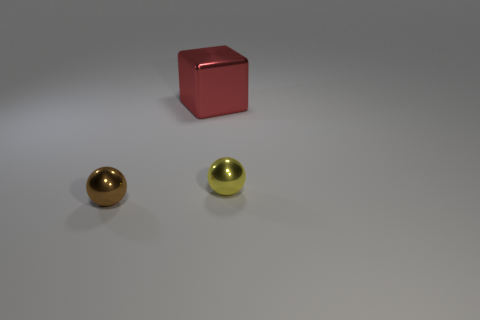What materials do the objects in the image seem to be made of? The objects present in the image appear to have different textures. The cube has a matte finish, suggesting it might be made of a material like painted plastic or metal, whereas the two spherical cylinders have a reflective surface that could indicate a material like polished metal or highly reflective plastic. 